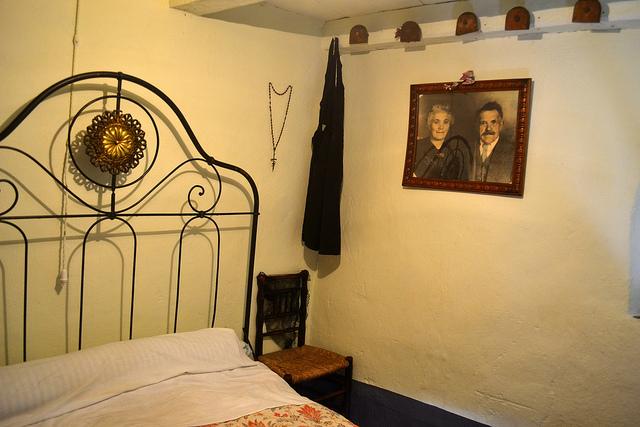Does this look like a hotel?
Answer briefly. No. What part of the house is this?
Quick response, please. Bedroom. How many pictures are on the wall?
Quick response, please. 1. How many people in the picture?
Short answer required. 2. What is the bed made of?
Short answer required. Metal. 